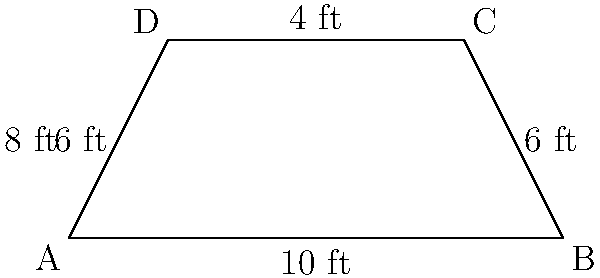A new trapezoidal serving counter is being designed for a school cafeteria to maximize the display area for fast food menu items. The counter measures 10 feet at the base, 4 feet at the top, and has a depth of 8 feet. What is the total surface area of the counter top in square feet? To find the surface area of the trapezoidal counter top, we need to calculate its area using the formula for the area of a trapezoid:

$$A = \frac{1}{2}(b_1 + b_2)h$$

Where:
$A$ = Area
$b_1$ = Length of one parallel side (base)
$b_2$ = Length of the other parallel side (top)
$h$ = Height (depth) of the trapezoid

Given:
$b_1 = 10$ feet (base)
$b_2 = 4$ feet (top)
$h = 8$ feet (depth)

Substituting these values into the formula:

$$A = \frac{1}{2}(10 + 4) \times 8$$
$$A = \frac{1}{2}(14) \times 8$$
$$A = 7 \times 8$$
$$A = 56$$

Therefore, the total surface area of the counter top is 56 square feet.
Answer: 56 sq ft 